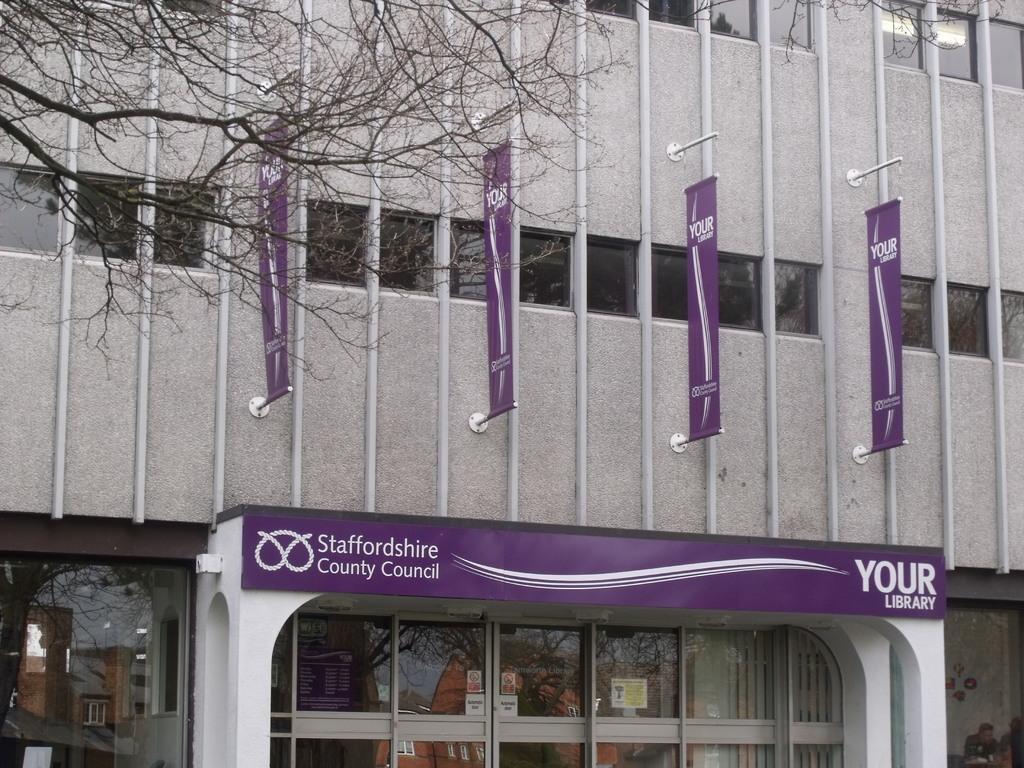Could you give a brief overview of what you see in this image? In this image we can see buildings, advertisement flags, poles, windows and store. 